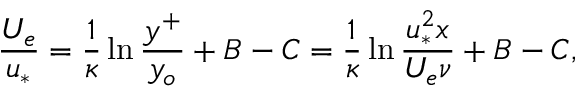Convert formula to latex. <formula><loc_0><loc_0><loc_500><loc_500>\frac { U _ { e } } { u _ { * } } = \frac { 1 } { \kappa } \ln \frac { y ^ { + } } { y _ { o } } + B - C = \frac { 1 } { \kappa } \ln \frac { u _ { * } ^ { 2 } x } { U _ { e } \nu } + B - C ,</formula> 